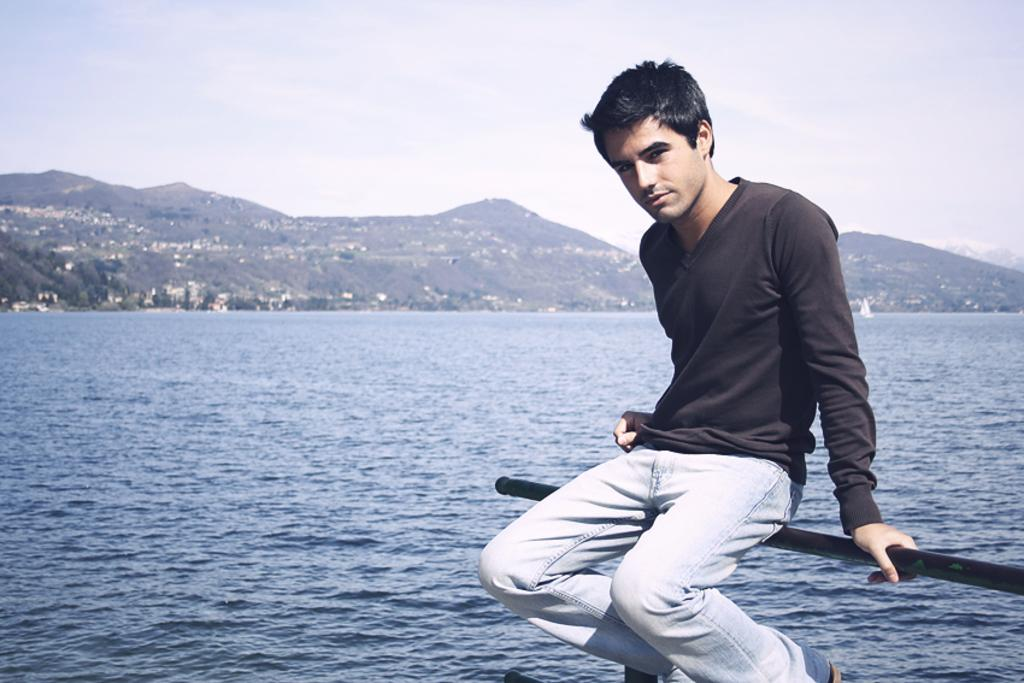What is the person in the image doing? The person is sitting on a pole in the image. What can be seen in the background of the image? There is water, trees, houses, hills, and the sky visible in the image. What type of coal is being used to fuel the car in the image? There is no car or coal present in the image. How is the oil being extracted from the ground in the image? There is no oil extraction activity depicted in the image. 